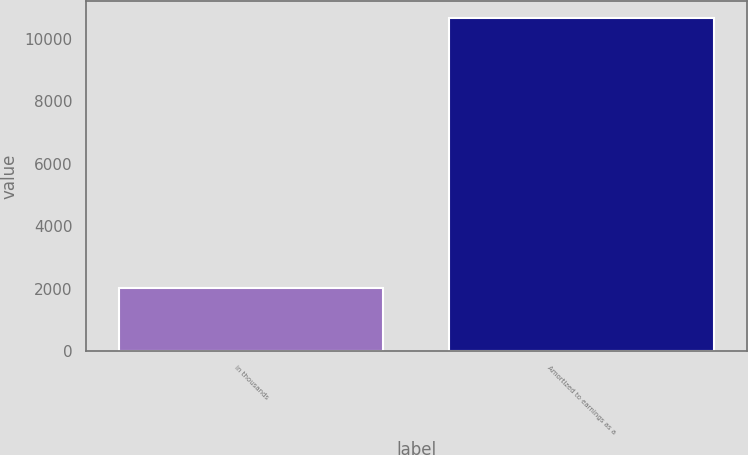Convert chart to OTSL. <chart><loc_0><loc_0><loc_500><loc_500><bar_chart><fcel>in thousands<fcel>Amortized to earnings as a<nl><fcel>2014<fcel>10674<nl></chart> 